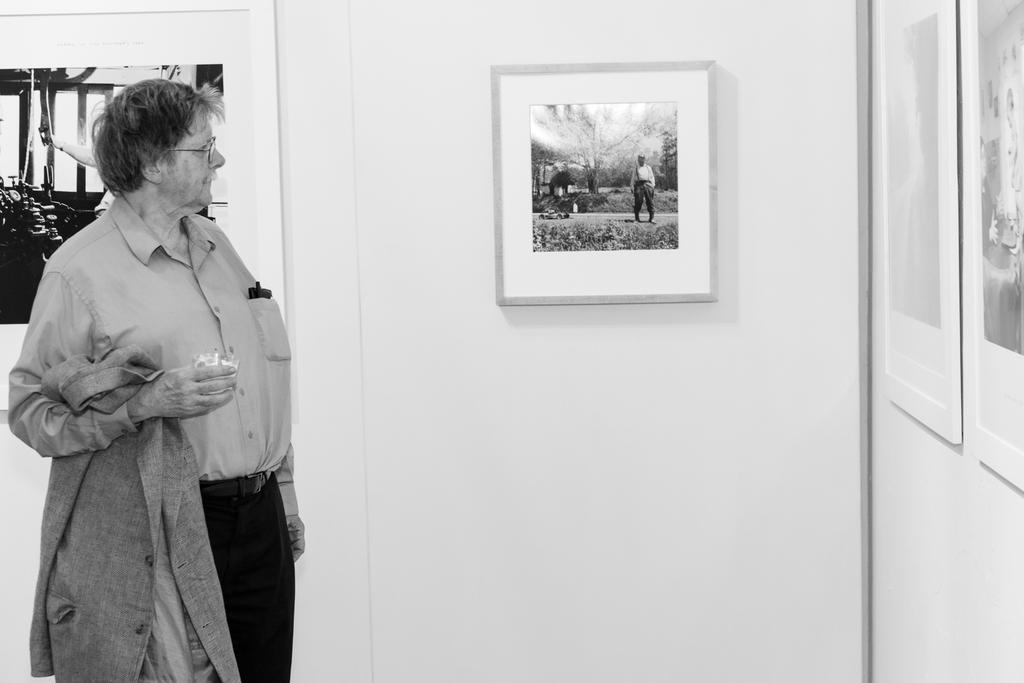Describe this image in one or two sentences. In the image we can see there is a man standing and he is holding jacket and cup in his hand. There are photo frames on the wall and the image is in black and white colour. 